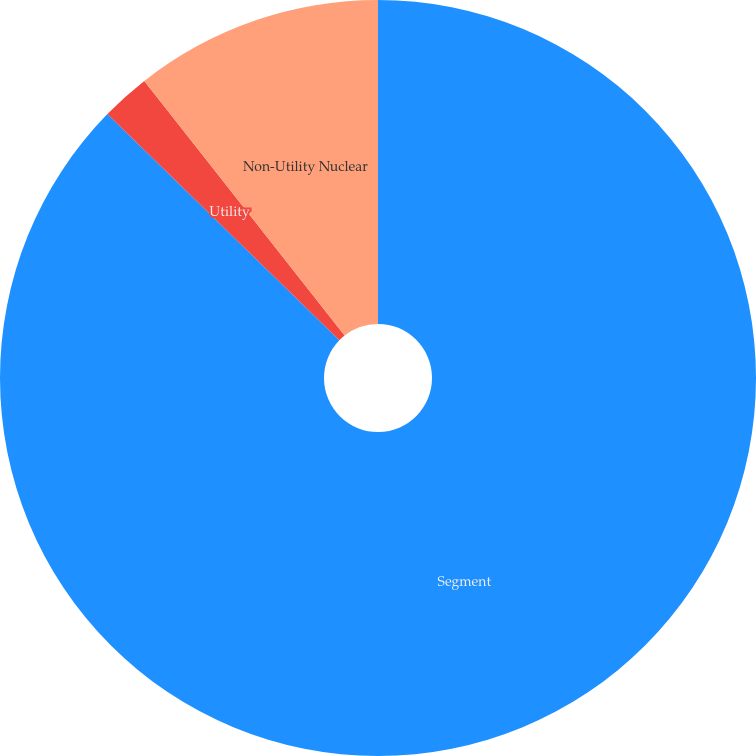Convert chart. <chart><loc_0><loc_0><loc_500><loc_500><pie_chart><fcel>Segment<fcel>Utility<fcel>Non-Utility Nuclear<nl><fcel>87.3%<fcel>2.09%<fcel>10.61%<nl></chart> 